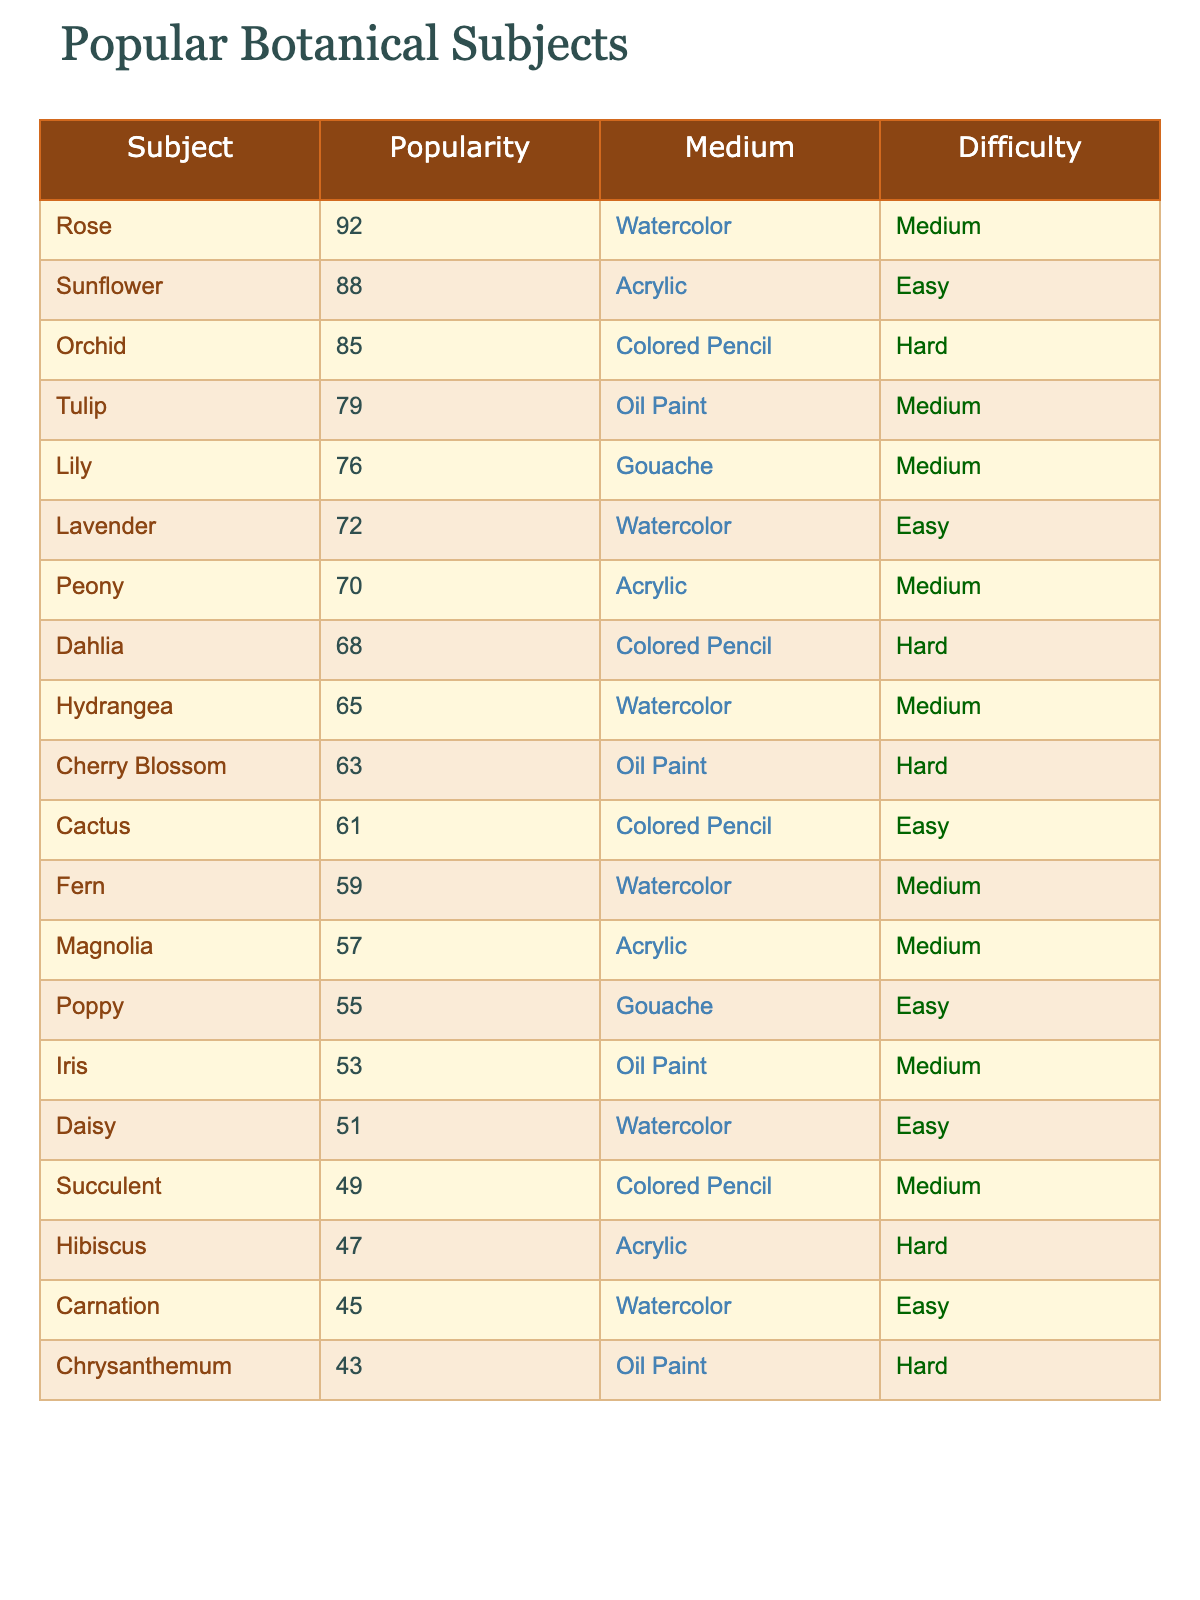What botanical subject has the highest popularity? The table shows the "Popularity" values for each subject. The highest value is 92, which corresponds to the "Rose".
Answer: Rose How many botanical subjects have a difficulty level of "Easy"? By counting the difficulty levels in the table, we see that "Sunflower", "Lavender", "Cactus", "Poppy", "Daisy", and "Carnation" are marked as "Easy", totaling 6 subjects.
Answer: 6 Which medium is used most frequently among popular botanical subjects? By examining the "Medium" column, we count occurrences: Watercolor (6), Acrylic (5), Colored Pencil (5), Oil Paint (4), and Gouache (3). Watercolor is the most common with 6 occurrences.
Answer: Watercolor What is the average popularity of subjects painted with "Acrylic"? Only the subjects "Sunflower", "Peony", "Magnolia", and "Hibiscus" are painted with Acrylic. Their popularity scores are 88, 70, 57, and 47. The total is 88 + 70 + 57 + 47 = 262; dividing by 4 gives an average of 65.5.
Answer: 65.5 Is "Orchid" easier to paint than "Cactus"? "Cactus" has a difficulty level of "Easy" while "Orchid" has a difficulty level of "Hard". Since "Easy" is less difficult than "Hard", we conclude "Cactus" is easier to paint.
Answer: Yes Which medium has both the highest and lowest popularity subjects? The highest popularity is the "Rose" with Watercolor as the medium (92), while the lowest popularity is "Chrysanthemum" with Oil Paint (43). Thus, Watercolor has the highest subject and Oil Paint has the lowest.
Answer: Watercolor and Oil Paint What is the total popularity score of all subjects painted with "Watercolor"? The subjects "Rose", "Lavender", "Hydrangea", "Fern", "Daisy", and "Carnation" use Watercolor. Their popularity scores are 92, 72, 65, 59, 51, and 45. Adding these gives 384.
Answer: 384 Are there more subjects marked as "Hard" or "Easy"? The subjects marked "Hard" are "Orchid", "Dahlia", "Cherry Blossom", "Hibiscus", and "Chrysanthemum", totaling 5 subjects. The "Easy" subjects are "Sunflower", "Lavender", "Cactus", "Poppy", "Daisy", and "Carnation", totaling 6 subjects. Since 6 > 5, there are more Easy subjects.
Answer: More Easy subjects What is the difference in popularity between the most and least popular subjects? The highest popularity is for "Rose" at 92 and the lowest is "Chrysanthemum" at 43. The difference is calculated as 92 - 43 = 49.
Answer: 49 What percentage of subjects are painted using "Colored Pencil"? There are a total of 20 subjects. Those painted with "Colored Pencil" are "Orchid", "Dahlia", "Cactus", and "Succulent", totaling 4 subjects. Thus, the percentage is (4/20) * 100 = 20%.
Answer: 20% 